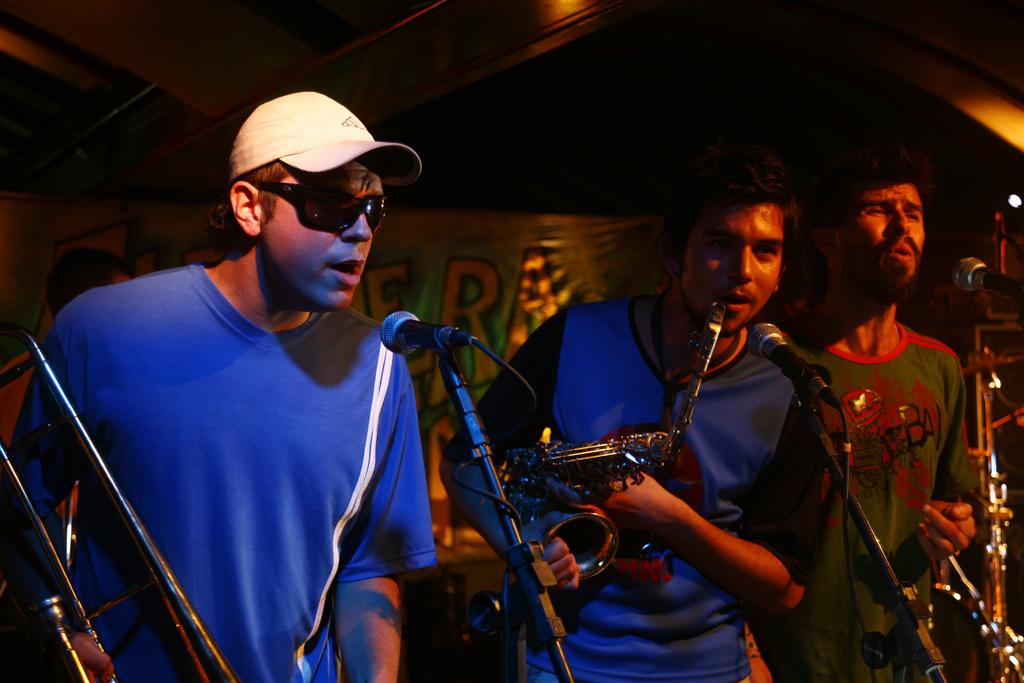What are the people in the image doing? The people in the image are singing. What objects are the people using while singing? The people are standing in front of microphones. What else can be seen in the image besides the people singing? There are musical instruments in the image. What is visible in the background of the image? There is a banner in the background of the image. How many zebras can be seen in the image? There are no zebras present in the image. What color is the sky in the image? The provided facts do not mention the color of the sky, and it is not visible in the image. 